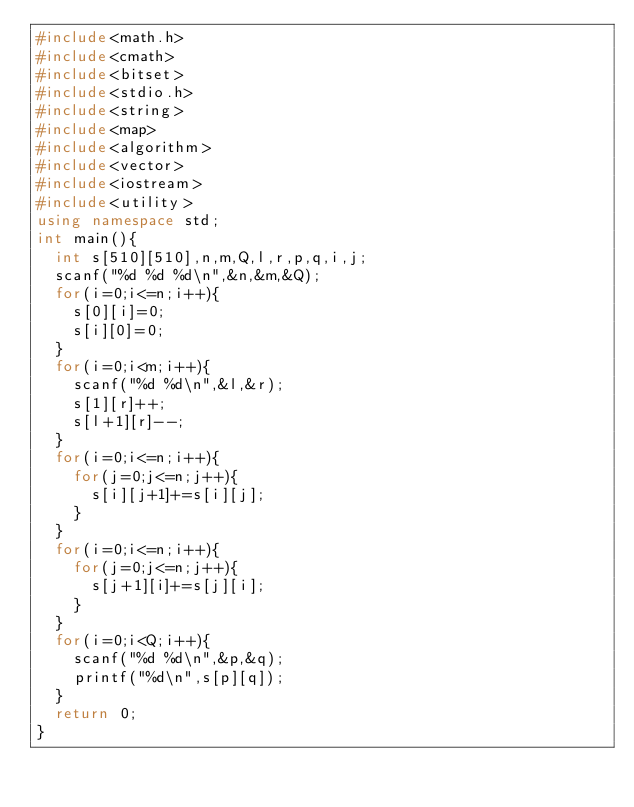<code> <loc_0><loc_0><loc_500><loc_500><_C++_>#include<math.h>
#include<cmath>
#include<bitset>
#include<stdio.h>
#include<string>
#include<map>
#include<algorithm>
#include<vector>
#include<iostream>
#include<utility>
using namespace std;
int main(){
  int s[510][510],n,m,Q,l,r,p,q,i,j;
  scanf("%d %d %d\n",&n,&m,&Q);
  for(i=0;i<=n;i++){
    s[0][i]=0;
    s[i][0]=0;
  }
  for(i=0;i<m;i++){
    scanf("%d %d\n",&l,&r);
    s[1][r]++;
    s[l+1][r]--;
  }
  for(i=0;i<=n;i++){
    for(j=0;j<=n;j++){
      s[i][j+1]+=s[i][j];
    }
  }
  for(i=0;i<=n;i++){
    for(j=0;j<=n;j++){
      s[j+1][i]+=s[j][i];
    }
  }
  for(i=0;i<Q;i++){
    scanf("%d %d\n",&p,&q);
    printf("%d\n",s[p][q]);
  }
  return 0;
}</code> 